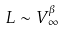Convert formula to latex. <formula><loc_0><loc_0><loc_500><loc_500>L \sim V _ { \infty } ^ { \beta }</formula> 